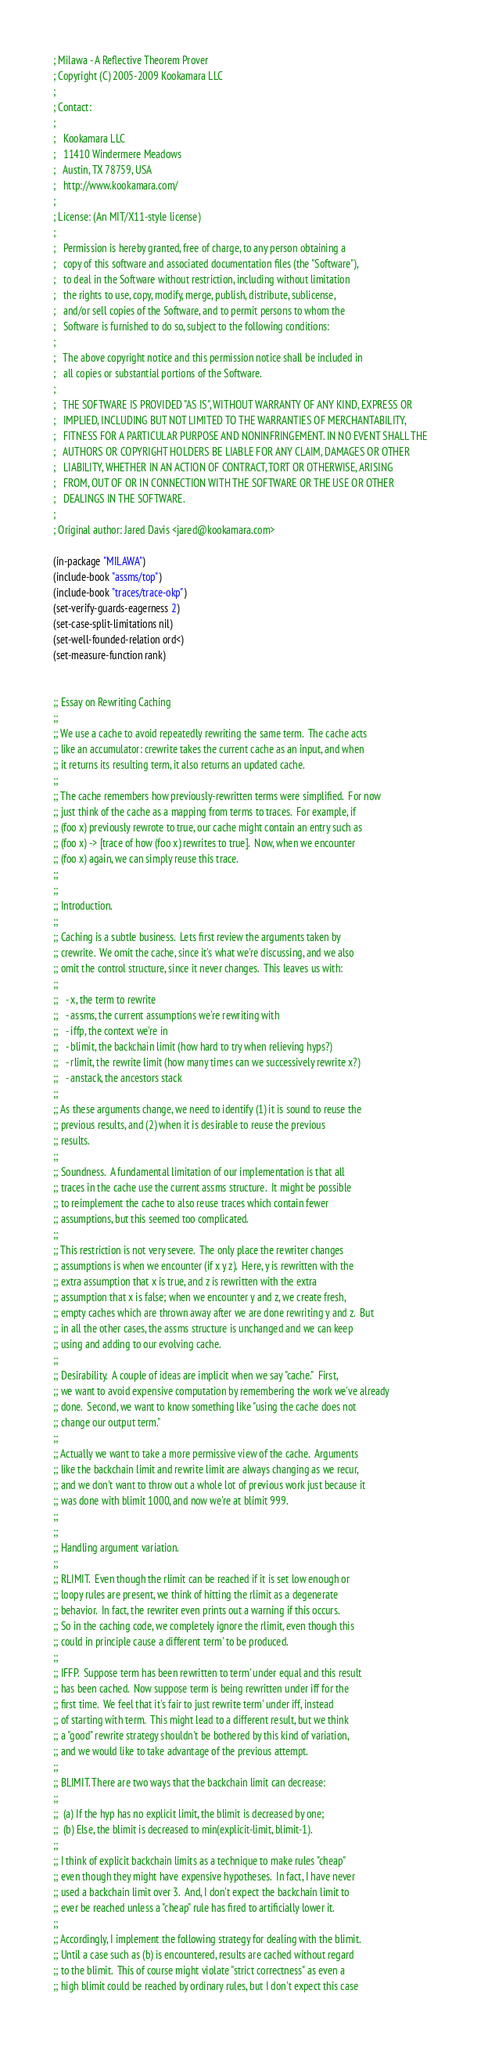<code> <loc_0><loc_0><loc_500><loc_500><_Lisp_>; Milawa - A Reflective Theorem Prover
; Copyright (C) 2005-2009 Kookamara LLC
;
; Contact:
;
;   Kookamara LLC
;   11410 Windermere Meadows
;   Austin, TX 78759, USA
;   http://www.kookamara.com/
;
; License: (An MIT/X11-style license)
;
;   Permission is hereby granted, free of charge, to any person obtaining a
;   copy of this software and associated documentation files (the "Software"),
;   to deal in the Software without restriction, including without limitation
;   the rights to use, copy, modify, merge, publish, distribute, sublicense,
;   and/or sell copies of the Software, and to permit persons to whom the
;   Software is furnished to do so, subject to the following conditions:
;
;   The above copyright notice and this permission notice shall be included in
;   all copies or substantial portions of the Software.
;
;   THE SOFTWARE IS PROVIDED "AS IS", WITHOUT WARRANTY OF ANY KIND, EXPRESS OR
;   IMPLIED, INCLUDING BUT NOT LIMITED TO THE WARRANTIES OF MERCHANTABILITY,
;   FITNESS FOR A PARTICULAR PURPOSE AND NONINFRINGEMENT. IN NO EVENT SHALL THE
;   AUTHORS OR COPYRIGHT HOLDERS BE LIABLE FOR ANY CLAIM, DAMAGES OR OTHER
;   LIABILITY, WHETHER IN AN ACTION OF CONTRACT, TORT OR OTHERWISE, ARISING
;   FROM, OUT OF OR IN CONNECTION WITH THE SOFTWARE OR THE USE OR OTHER
;   DEALINGS IN THE SOFTWARE.
;
; Original author: Jared Davis <jared@kookamara.com>

(in-package "MILAWA")
(include-book "assms/top")
(include-book "traces/trace-okp")
(set-verify-guards-eagerness 2)
(set-case-split-limitations nil)
(set-well-founded-relation ord<)
(set-measure-function rank)


;; Essay on Rewriting Caching
;;
;; We use a cache to avoid repeatedly rewriting the same term.  The cache acts
;; like an accumulator: crewrite takes the current cache as an input, and when
;; it returns its resulting term, it also returns an updated cache.
;;
;; The cache remembers how previously-rewritten terms were simplified.  For now
;; just think of the cache as a mapping from terms to traces.  For example, if
;; (foo x) previously rewrote to true, our cache might contain an entry such as
;; (foo x) -> [trace of how (foo x) rewrites to true].  Now, when we encounter
;; (foo x) again, we can simply reuse this trace.
;;
;;
;; Introduction.
;;
;; Caching is a subtle business.  Lets first review the arguments taken by
;; crewrite.  We omit the cache, since it's what we're discussing, and we also
;; omit the control structure, since it never changes.  This leaves us with:
;;
;;   - x, the term to rewrite
;;   - assms, the current assumptions we're rewriting with
;;   - iffp, the context we're in
;;   - blimit, the backchain limit (how hard to try when relieving hyps?)
;;   - rlimit, the rewrite limit (how many times can we successively rewrite x?)
;;   - anstack, the ancestors stack
;;
;; As these arguments change, we need to identify (1) it is sound to reuse the
;; previous results, and (2) when it is desirable to reuse the previous
;; results.
;;
;; Soundness.  A fundamental limitation of our implementation is that all
;; traces in the cache use the current assms structure.  It might be possible
;; to reimplement the cache to also reuse traces which contain fewer
;; assumptions, but this seemed too complicated.
;;
;; This restriction is not very severe.  The only place the rewriter changes
;; assumptions is when we encounter (if x y z).  Here, y is rewritten with the
;; extra assumption that x is true, and z is rewritten with the extra
;; assumption that x is false; when we encounter y and z, we create fresh,
;; empty caches which are thrown away after we are done rewriting y and z.  But
;; in all the other cases, the assms structure is unchanged and we can keep
;; using and adding to our evolving cache.
;;
;; Desirability.  A couple of ideas are implicit when we say "cache."  First,
;; we want to avoid expensive computation by remembering the work we've already
;; done.  Second, we want to know something like "using the cache does not
;; change our output term."
;;
;; Actually we want to take a more permissive view of the cache.  Arguments
;; like the backchain limit and rewrite limit are always changing as we recur,
;; and we don't want to throw out a whole lot of previous work just because it
;; was done with blimit 1000, and now we're at blimit 999.
;;
;;
;; Handling argument variation.
;;
;; RLIMIT.  Even though the rlimit can be reached if it is set low enough or
;; loopy rules are present, we think of hitting the rlimit as a degenerate
;; behavior.  In fact, the rewriter even prints out a warning if this occurs.
;; So in the caching code, we completely ignore the rlimit, even though this
;; could in principle cause a different term' to be produced.
;;
;; IFFP.  Suppose term has been rewritten to term' under equal and this result
;; has been cached.  Now suppose term is being rewritten under iff for the
;; first time.  We feel that it's fair to just rewrite term' under iff, instead
;; of starting with term.  This might lead to a different result, but we think
;; a "good" rewrite strategy shouldn't be bothered by this kind of variation,
;; and we would like to take advantage of the previous attempt.
;;
;; BLIMIT. There are two ways that the backchain limit can decrease:
;;
;;  (a) If the hyp has no explicit limit, the blimit is decreased by one;
;;  (b) Else, the blimit is decreased to min(explicit-limit, blimit-1).
;;
;; I think of explicit backchain limits as a technique to make rules "cheap"
;; even though they might have expensive hypotheses.  In fact, I have never
;; used a backchain limit over 3.  And, I don't expect the backchain limit to
;; ever be reached unless a "cheap" rule has fired to artificially lower it.
;;
;; Accordingly, I implement the following strategy for dealing with the blimit.
;; Until a case such as (b) is encountered, results are cached without regard
;; to the blimit.  This of course might violate "strict correctness" as even a
;; high blimit could be reached by ordinary rules, but I don't expect this case</code> 